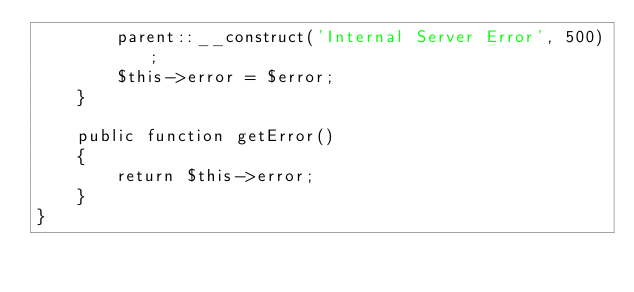<code> <loc_0><loc_0><loc_500><loc_500><_PHP_>        parent::__construct('Internal Server Error', 500);
        $this->error = $error;
    }

    public function getError()
    {
        return $this->error;
    }
}
</code> 